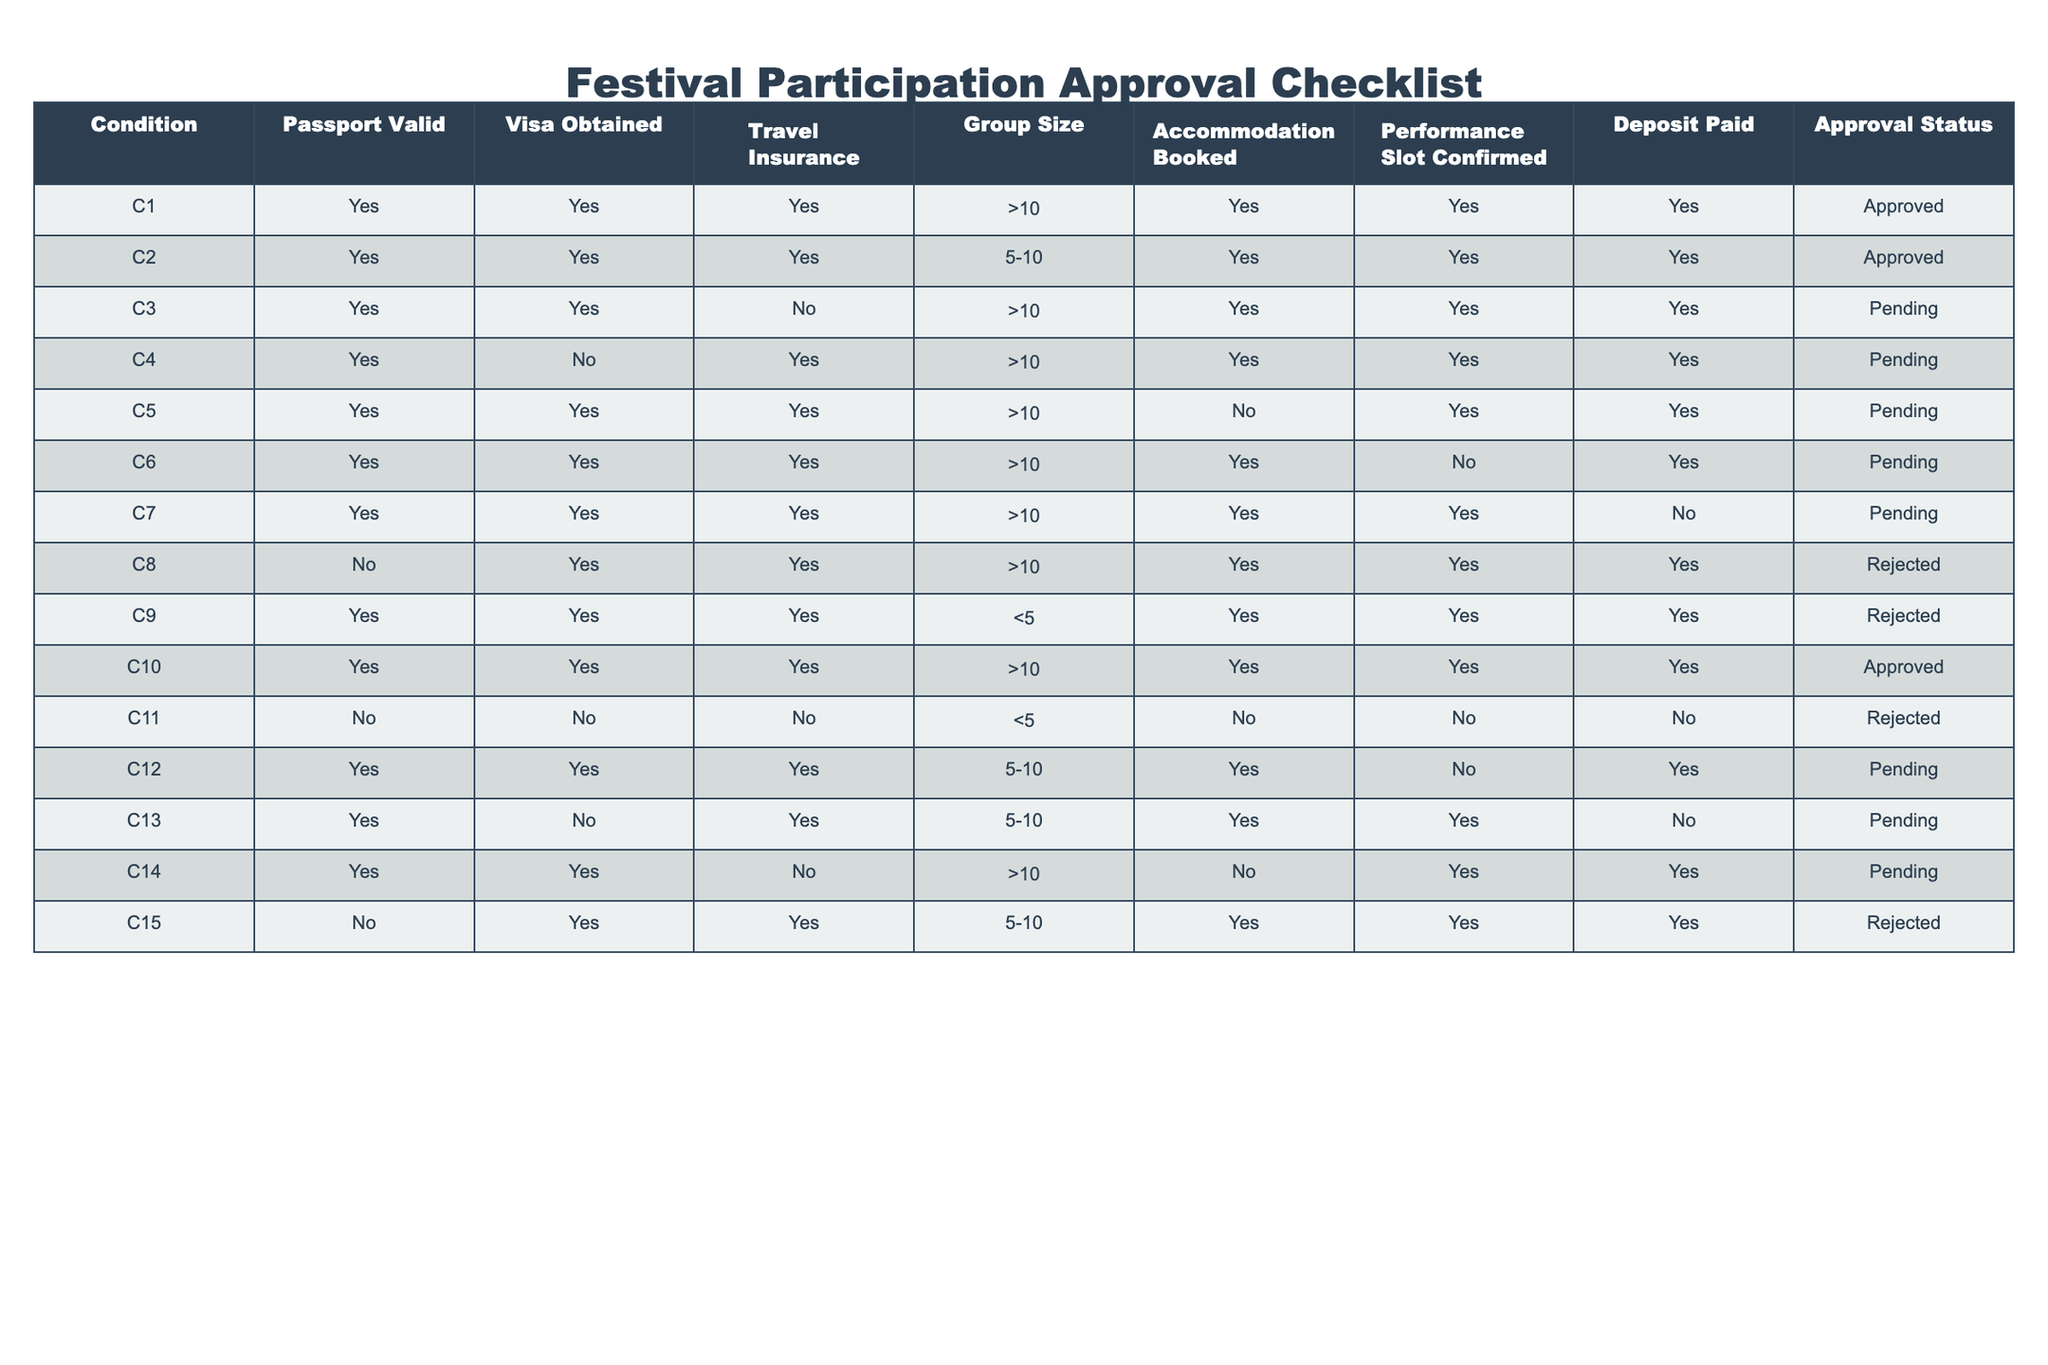What is the approval status for the group with more than 10 members, who have obtained a visa, and have travel insurance? Looking at the table, there are two rows with more than 10 members who have visas and insurance. The first one (C1) is marked as Approved, and the second (C7) is Pending. Hence, the answer to the question is that the status can either be Approved or Pending, depending on other factors.
Answer: Approved or Pending How many groups are in the Pending status? By inspecting the table, there are 5 entries that are marked as Pending: C3, C4, C5, C6, C7, and C12. Therefore, to count them, we find a total of 6 rows.
Answer: 6 Is there a group that was rejected despite having a visa and travel insurance? By reviewing the entries, we find that C8 had a visa and travel insurance but was still rejected due to the passport status. This satisfies the criteria of being rejected with those conditions.
Answer: Yes What is the total number of groups with approval status other than Approved? In the table, the entries with statuses other than Approved are those marked as Pending and Rejected. There are 6 Pending (C3, C4, C5, C6, C7, C12) and 5 Rejected (C8, C9, C11, C15), which sums up to 11 groups.
Answer: 11 How many groups have been approved and have booked accommodations? The groups that are Approved are C1, C2, and C10. All these groups have booked accommodations, so we can confidently say that all approved groups have secured their lodging.
Answer: 3 What is the average group size for the Pending groups? The Pending groups are C3, C4, C5, C6, C7, and C12. They have sizes (noted in >10, 5-10, and exact numbers): 11 (C3), 11 (C4), 11 (C5), 11 (C6), 11 (C7), and 10 (C12). Summing them up gives us (11 + 11 + 11 + 11 + 11 + 10 = 65) and dividing by 6 (total groups) gives us an average of 10.83.
Answer: 10.83 